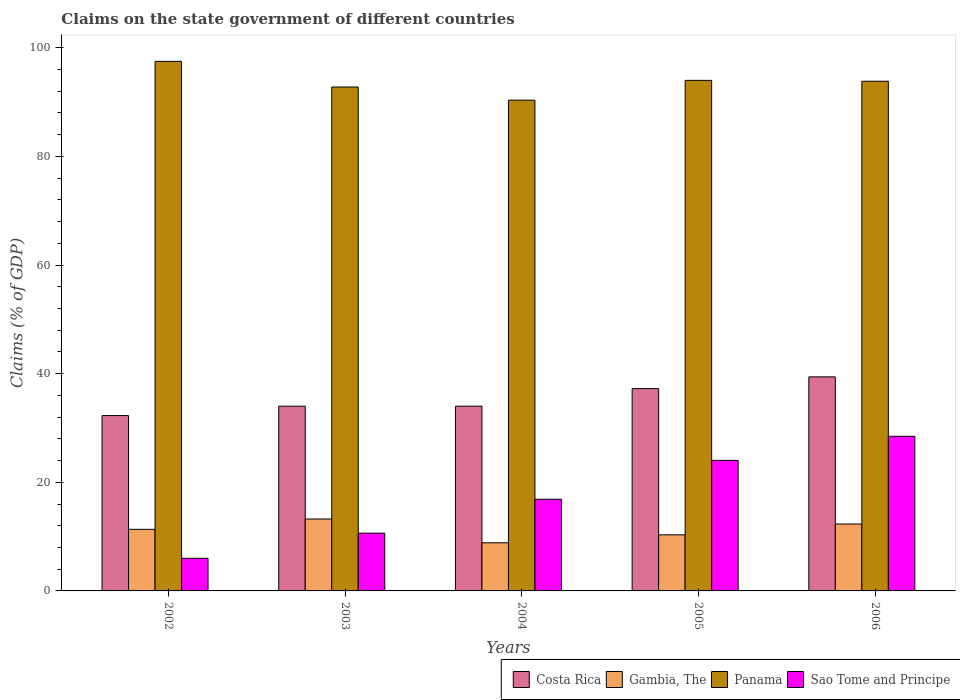Are the number of bars on each tick of the X-axis equal?
Give a very brief answer. Yes. How many bars are there on the 2nd tick from the right?
Give a very brief answer. 4. What is the percentage of GDP claimed on the state government in Panama in 2002?
Your response must be concise. 97.5. Across all years, what is the maximum percentage of GDP claimed on the state government in Costa Rica?
Provide a succinct answer. 39.41. Across all years, what is the minimum percentage of GDP claimed on the state government in Panama?
Give a very brief answer. 90.35. In which year was the percentage of GDP claimed on the state government in Sao Tome and Principe maximum?
Provide a succinct answer. 2006. In which year was the percentage of GDP claimed on the state government in Gambia, The minimum?
Your answer should be very brief. 2004. What is the total percentage of GDP claimed on the state government in Costa Rica in the graph?
Keep it short and to the point. 176.97. What is the difference between the percentage of GDP claimed on the state government in Gambia, The in 2004 and that in 2005?
Provide a succinct answer. -1.46. What is the difference between the percentage of GDP claimed on the state government in Sao Tome and Principe in 2005 and the percentage of GDP claimed on the state government in Gambia, The in 2002?
Your answer should be very brief. 12.7. What is the average percentage of GDP claimed on the state government in Costa Rica per year?
Provide a short and direct response. 35.39. In the year 2002, what is the difference between the percentage of GDP claimed on the state government in Costa Rica and percentage of GDP claimed on the state government in Gambia, The?
Keep it short and to the point. 20.94. In how many years, is the percentage of GDP claimed on the state government in Costa Rica greater than 56 %?
Your answer should be compact. 0. What is the ratio of the percentage of GDP claimed on the state government in Sao Tome and Principe in 2003 to that in 2005?
Your response must be concise. 0.44. Is the percentage of GDP claimed on the state government in Panama in 2003 less than that in 2004?
Provide a short and direct response. No. Is the difference between the percentage of GDP claimed on the state government in Costa Rica in 2004 and 2005 greater than the difference between the percentage of GDP claimed on the state government in Gambia, The in 2004 and 2005?
Your response must be concise. No. What is the difference between the highest and the second highest percentage of GDP claimed on the state government in Gambia, The?
Provide a succinct answer. 0.92. What is the difference between the highest and the lowest percentage of GDP claimed on the state government in Costa Rica?
Ensure brevity in your answer.  7.13. In how many years, is the percentage of GDP claimed on the state government in Panama greater than the average percentage of GDP claimed on the state government in Panama taken over all years?
Ensure brevity in your answer.  3. Is it the case that in every year, the sum of the percentage of GDP claimed on the state government in Sao Tome and Principe and percentage of GDP claimed on the state government in Gambia, The is greater than the sum of percentage of GDP claimed on the state government in Panama and percentage of GDP claimed on the state government in Costa Rica?
Provide a succinct answer. No. What does the 4th bar from the left in 2004 represents?
Your response must be concise. Sao Tome and Principe. What does the 1st bar from the right in 2005 represents?
Give a very brief answer. Sao Tome and Principe. Is it the case that in every year, the sum of the percentage of GDP claimed on the state government in Costa Rica and percentage of GDP claimed on the state government in Gambia, The is greater than the percentage of GDP claimed on the state government in Panama?
Give a very brief answer. No. Are all the bars in the graph horizontal?
Keep it short and to the point. No. Are the values on the major ticks of Y-axis written in scientific E-notation?
Offer a very short reply. No. Where does the legend appear in the graph?
Your answer should be compact. Bottom right. How many legend labels are there?
Your answer should be compact. 4. What is the title of the graph?
Your answer should be compact. Claims on the state government of different countries. Does "Belarus" appear as one of the legend labels in the graph?
Ensure brevity in your answer.  No. What is the label or title of the Y-axis?
Make the answer very short. Claims (% of GDP). What is the Claims (% of GDP) in Costa Rica in 2002?
Provide a succinct answer. 32.28. What is the Claims (% of GDP) of Gambia, The in 2002?
Give a very brief answer. 11.34. What is the Claims (% of GDP) of Panama in 2002?
Provide a succinct answer. 97.5. What is the Claims (% of GDP) in Sao Tome and Principe in 2002?
Your answer should be compact. 6.01. What is the Claims (% of GDP) of Costa Rica in 2003?
Keep it short and to the point. 34.01. What is the Claims (% of GDP) of Gambia, The in 2003?
Offer a terse response. 13.24. What is the Claims (% of GDP) of Panama in 2003?
Your answer should be compact. 92.78. What is the Claims (% of GDP) in Sao Tome and Principe in 2003?
Offer a terse response. 10.64. What is the Claims (% of GDP) of Costa Rica in 2004?
Give a very brief answer. 34.02. What is the Claims (% of GDP) in Gambia, The in 2004?
Ensure brevity in your answer.  8.86. What is the Claims (% of GDP) of Panama in 2004?
Your answer should be very brief. 90.35. What is the Claims (% of GDP) in Sao Tome and Principe in 2004?
Your answer should be very brief. 16.88. What is the Claims (% of GDP) in Costa Rica in 2005?
Ensure brevity in your answer.  37.25. What is the Claims (% of GDP) in Gambia, The in 2005?
Offer a terse response. 10.32. What is the Claims (% of GDP) in Panama in 2005?
Offer a terse response. 94. What is the Claims (% of GDP) in Sao Tome and Principe in 2005?
Your answer should be compact. 24.04. What is the Claims (% of GDP) in Costa Rica in 2006?
Give a very brief answer. 39.41. What is the Claims (% of GDP) of Gambia, The in 2006?
Your answer should be compact. 12.32. What is the Claims (% of GDP) in Panama in 2006?
Make the answer very short. 93.84. What is the Claims (% of GDP) in Sao Tome and Principe in 2006?
Offer a terse response. 28.47. Across all years, what is the maximum Claims (% of GDP) of Costa Rica?
Your answer should be compact. 39.41. Across all years, what is the maximum Claims (% of GDP) in Gambia, The?
Make the answer very short. 13.24. Across all years, what is the maximum Claims (% of GDP) of Panama?
Offer a very short reply. 97.5. Across all years, what is the maximum Claims (% of GDP) in Sao Tome and Principe?
Your response must be concise. 28.47. Across all years, what is the minimum Claims (% of GDP) of Costa Rica?
Your answer should be compact. 32.28. Across all years, what is the minimum Claims (% of GDP) in Gambia, The?
Keep it short and to the point. 8.86. Across all years, what is the minimum Claims (% of GDP) of Panama?
Your response must be concise. 90.35. Across all years, what is the minimum Claims (% of GDP) of Sao Tome and Principe?
Your answer should be compact. 6.01. What is the total Claims (% of GDP) in Costa Rica in the graph?
Offer a very short reply. 176.97. What is the total Claims (% of GDP) of Gambia, The in the graph?
Ensure brevity in your answer.  56.08. What is the total Claims (% of GDP) in Panama in the graph?
Ensure brevity in your answer.  468.46. What is the total Claims (% of GDP) of Sao Tome and Principe in the graph?
Keep it short and to the point. 86.03. What is the difference between the Claims (% of GDP) in Costa Rica in 2002 and that in 2003?
Provide a short and direct response. -1.73. What is the difference between the Claims (% of GDP) in Gambia, The in 2002 and that in 2003?
Provide a succinct answer. -1.9. What is the difference between the Claims (% of GDP) of Panama in 2002 and that in 2003?
Your answer should be very brief. 4.72. What is the difference between the Claims (% of GDP) of Sao Tome and Principe in 2002 and that in 2003?
Offer a terse response. -4.63. What is the difference between the Claims (% of GDP) in Costa Rica in 2002 and that in 2004?
Provide a succinct answer. -1.73. What is the difference between the Claims (% of GDP) of Gambia, The in 2002 and that in 2004?
Ensure brevity in your answer.  2.48. What is the difference between the Claims (% of GDP) of Panama in 2002 and that in 2004?
Provide a short and direct response. 7.15. What is the difference between the Claims (% of GDP) of Sao Tome and Principe in 2002 and that in 2004?
Offer a very short reply. -10.87. What is the difference between the Claims (% of GDP) in Costa Rica in 2002 and that in 2005?
Provide a succinct answer. -4.96. What is the difference between the Claims (% of GDP) of Gambia, The in 2002 and that in 2005?
Keep it short and to the point. 1.01. What is the difference between the Claims (% of GDP) in Panama in 2002 and that in 2005?
Provide a succinct answer. 3.5. What is the difference between the Claims (% of GDP) in Sao Tome and Principe in 2002 and that in 2005?
Your response must be concise. -18.03. What is the difference between the Claims (% of GDP) in Costa Rica in 2002 and that in 2006?
Your answer should be very brief. -7.13. What is the difference between the Claims (% of GDP) in Gambia, The in 2002 and that in 2006?
Provide a succinct answer. -0.98. What is the difference between the Claims (% of GDP) in Panama in 2002 and that in 2006?
Offer a terse response. 3.66. What is the difference between the Claims (% of GDP) in Sao Tome and Principe in 2002 and that in 2006?
Make the answer very short. -22.46. What is the difference between the Claims (% of GDP) of Costa Rica in 2003 and that in 2004?
Provide a succinct answer. -0. What is the difference between the Claims (% of GDP) in Gambia, The in 2003 and that in 2004?
Provide a succinct answer. 4.38. What is the difference between the Claims (% of GDP) in Panama in 2003 and that in 2004?
Give a very brief answer. 2.42. What is the difference between the Claims (% of GDP) of Sao Tome and Principe in 2003 and that in 2004?
Make the answer very short. -6.24. What is the difference between the Claims (% of GDP) of Costa Rica in 2003 and that in 2005?
Provide a succinct answer. -3.23. What is the difference between the Claims (% of GDP) in Gambia, The in 2003 and that in 2005?
Offer a very short reply. 2.92. What is the difference between the Claims (% of GDP) of Panama in 2003 and that in 2005?
Your response must be concise. -1.22. What is the difference between the Claims (% of GDP) of Sao Tome and Principe in 2003 and that in 2005?
Offer a very short reply. -13.4. What is the difference between the Claims (% of GDP) of Costa Rica in 2003 and that in 2006?
Your response must be concise. -5.4. What is the difference between the Claims (% of GDP) of Gambia, The in 2003 and that in 2006?
Provide a succinct answer. 0.92. What is the difference between the Claims (% of GDP) of Panama in 2003 and that in 2006?
Keep it short and to the point. -1.06. What is the difference between the Claims (% of GDP) in Sao Tome and Principe in 2003 and that in 2006?
Provide a succinct answer. -17.83. What is the difference between the Claims (% of GDP) of Costa Rica in 2004 and that in 2005?
Your answer should be compact. -3.23. What is the difference between the Claims (% of GDP) of Gambia, The in 2004 and that in 2005?
Provide a short and direct response. -1.46. What is the difference between the Claims (% of GDP) in Panama in 2004 and that in 2005?
Ensure brevity in your answer.  -3.64. What is the difference between the Claims (% of GDP) of Sao Tome and Principe in 2004 and that in 2005?
Your answer should be compact. -7.16. What is the difference between the Claims (% of GDP) in Costa Rica in 2004 and that in 2006?
Your answer should be compact. -5.39. What is the difference between the Claims (% of GDP) of Gambia, The in 2004 and that in 2006?
Offer a terse response. -3.46. What is the difference between the Claims (% of GDP) of Panama in 2004 and that in 2006?
Give a very brief answer. -3.48. What is the difference between the Claims (% of GDP) of Sao Tome and Principe in 2004 and that in 2006?
Provide a succinct answer. -11.59. What is the difference between the Claims (% of GDP) in Costa Rica in 2005 and that in 2006?
Your response must be concise. -2.16. What is the difference between the Claims (% of GDP) of Gambia, The in 2005 and that in 2006?
Offer a very short reply. -1.99. What is the difference between the Claims (% of GDP) of Panama in 2005 and that in 2006?
Provide a succinct answer. 0.16. What is the difference between the Claims (% of GDP) in Sao Tome and Principe in 2005 and that in 2006?
Offer a very short reply. -4.43. What is the difference between the Claims (% of GDP) of Costa Rica in 2002 and the Claims (% of GDP) of Gambia, The in 2003?
Your response must be concise. 19.04. What is the difference between the Claims (% of GDP) in Costa Rica in 2002 and the Claims (% of GDP) in Panama in 2003?
Your answer should be very brief. -60.49. What is the difference between the Claims (% of GDP) in Costa Rica in 2002 and the Claims (% of GDP) in Sao Tome and Principe in 2003?
Provide a succinct answer. 21.65. What is the difference between the Claims (% of GDP) of Gambia, The in 2002 and the Claims (% of GDP) of Panama in 2003?
Provide a succinct answer. -81.44. What is the difference between the Claims (% of GDP) of Gambia, The in 2002 and the Claims (% of GDP) of Sao Tome and Principe in 2003?
Provide a short and direct response. 0.7. What is the difference between the Claims (% of GDP) of Panama in 2002 and the Claims (% of GDP) of Sao Tome and Principe in 2003?
Provide a succinct answer. 86.86. What is the difference between the Claims (% of GDP) in Costa Rica in 2002 and the Claims (% of GDP) in Gambia, The in 2004?
Provide a short and direct response. 23.42. What is the difference between the Claims (% of GDP) in Costa Rica in 2002 and the Claims (% of GDP) in Panama in 2004?
Make the answer very short. -58.07. What is the difference between the Claims (% of GDP) in Costa Rica in 2002 and the Claims (% of GDP) in Sao Tome and Principe in 2004?
Provide a short and direct response. 15.4. What is the difference between the Claims (% of GDP) of Gambia, The in 2002 and the Claims (% of GDP) of Panama in 2004?
Offer a terse response. -79.01. What is the difference between the Claims (% of GDP) of Gambia, The in 2002 and the Claims (% of GDP) of Sao Tome and Principe in 2004?
Give a very brief answer. -5.54. What is the difference between the Claims (% of GDP) in Panama in 2002 and the Claims (% of GDP) in Sao Tome and Principe in 2004?
Ensure brevity in your answer.  80.62. What is the difference between the Claims (% of GDP) in Costa Rica in 2002 and the Claims (% of GDP) in Gambia, The in 2005?
Ensure brevity in your answer.  21.96. What is the difference between the Claims (% of GDP) in Costa Rica in 2002 and the Claims (% of GDP) in Panama in 2005?
Offer a very short reply. -61.71. What is the difference between the Claims (% of GDP) in Costa Rica in 2002 and the Claims (% of GDP) in Sao Tome and Principe in 2005?
Offer a very short reply. 8.25. What is the difference between the Claims (% of GDP) of Gambia, The in 2002 and the Claims (% of GDP) of Panama in 2005?
Provide a short and direct response. -82.66. What is the difference between the Claims (% of GDP) in Gambia, The in 2002 and the Claims (% of GDP) in Sao Tome and Principe in 2005?
Make the answer very short. -12.7. What is the difference between the Claims (% of GDP) of Panama in 2002 and the Claims (% of GDP) of Sao Tome and Principe in 2005?
Your answer should be very brief. 73.46. What is the difference between the Claims (% of GDP) of Costa Rica in 2002 and the Claims (% of GDP) of Gambia, The in 2006?
Your answer should be very brief. 19.97. What is the difference between the Claims (% of GDP) in Costa Rica in 2002 and the Claims (% of GDP) in Panama in 2006?
Your response must be concise. -61.55. What is the difference between the Claims (% of GDP) in Costa Rica in 2002 and the Claims (% of GDP) in Sao Tome and Principe in 2006?
Make the answer very short. 3.81. What is the difference between the Claims (% of GDP) in Gambia, The in 2002 and the Claims (% of GDP) in Panama in 2006?
Ensure brevity in your answer.  -82.5. What is the difference between the Claims (% of GDP) in Gambia, The in 2002 and the Claims (% of GDP) in Sao Tome and Principe in 2006?
Your answer should be compact. -17.13. What is the difference between the Claims (% of GDP) of Panama in 2002 and the Claims (% of GDP) of Sao Tome and Principe in 2006?
Give a very brief answer. 69.03. What is the difference between the Claims (% of GDP) in Costa Rica in 2003 and the Claims (% of GDP) in Gambia, The in 2004?
Provide a short and direct response. 25.15. What is the difference between the Claims (% of GDP) in Costa Rica in 2003 and the Claims (% of GDP) in Panama in 2004?
Offer a terse response. -56.34. What is the difference between the Claims (% of GDP) of Costa Rica in 2003 and the Claims (% of GDP) of Sao Tome and Principe in 2004?
Keep it short and to the point. 17.13. What is the difference between the Claims (% of GDP) of Gambia, The in 2003 and the Claims (% of GDP) of Panama in 2004?
Your answer should be very brief. -77.11. What is the difference between the Claims (% of GDP) in Gambia, The in 2003 and the Claims (% of GDP) in Sao Tome and Principe in 2004?
Ensure brevity in your answer.  -3.64. What is the difference between the Claims (% of GDP) of Panama in 2003 and the Claims (% of GDP) of Sao Tome and Principe in 2004?
Your answer should be very brief. 75.9. What is the difference between the Claims (% of GDP) in Costa Rica in 2003 and the Claims (% of GDP) in Gambia, The in 2005?
Provide a short and direct response. 23.69. What is the difference between the Claims (% of GDP) in Costa Rica in 2003 and the Claims (% of GDP) in Panama in 2005?
Offer a terse response. -59.98. What is the difference between the Claims (% of GDP) in Costa Rica in 2003 and the Claims (% of GDP) in Sao Tome and Principe in 2005?
Your answer should be compact. 9.98. What is the difference between the Claims (% of GDP) in Gambia, The in 2003 and the Claims (% of GDP) in Panama in 2005?
Ensure brevity in your answer.  -80.76. What is the difference between the Claims (% of GDP) of Gambia, The in 2003 and the Claims (% of GDP) of Sao Tome and Principe in 2005?
Offer a very short reply. -10.8. What is the difference between the Claims (% of GDP) of Panama in 2003 and the Claims (% of GDP) of Sao Tome and Principe in 2005?
Ensure brevity in your answer.  68.74. What is the difference between the Claims (% of GDP) of Costa Rica in 2003 and the Claims (% of GDP) of Gambia, The in 2006?
Keep it short and to the point. 21.7. What is the difference between the Claims (% of GDP) in Costa Rica in 2003 and the Claims (% of GDP) in Panama in 2006?
Your response must be concise. -59.82. What is the difference between the Claims (% of GDP) of Costa Rica in 2003 and the Claims (% of GDP) of Sao Tome and Principe in 2006?
Your answer should be compact. 5.54. What is the difference between the Claims (% of GDP) of Gambia, The in 2003 and the Claims (% of GDP) of Panama in 2006?
Provide a succinct answer. -80.6. What is the difference between the Claims (% of GDP) of Gambia, The in 2003 and the Claims (% of GDP) of Sao Tome and Principe in 2006?
Your response must be concise. -15.23. What is the difference between the Claims (% of GDP) of Panama in 2003 and the Claims (% of GDP) of Sao Tome and Principe in 2006?
Offer a terse response. 64.31. What is the difference between the Claims (% of GDP) in Costa Rica in 2004 and the Claims (% of GDP) in Gambia, The in 2005?
Your answer should be very brief. 23.69. What is the difference between the Claims (% of GDP) of Costa Rica in 2004 and the Claims (% of GDP) of Panama in 2005?
Keep it short and to the point. -59.98. What is the difference between the Claims (% of GDP) of Costa Rica in 2004 and the Claims (% of GDP) of Sao Tome and Principe in 2005?
Ensure brevity in your answer.  9.98. What is the difference between the Claims (% of GDP) in Gambia, The in 2004 and the Claims (% of GDP) in Panama in 2005?
Your answer should be compact. -85.14. What is the difference between the Claims (% of GDP) of Gambia, The in 2004 and the Claims (% of GDP) of Sao Tome and Principe in 2005?
Offer a very short reply. -15.17. What is the difference between the Claims (% of GDP) in Panama in 2004 and the Claims (% of GDP) in Sao Tome and Principe in 2005?
Your response must be concise. 66.32. What is the difference between the Claims (% of GDP) in Costa Rica in 2004 and the Claims (% of GDP) in Gambia, The in 2006?
Give a very brief answer. 21.7. What is the difference between the Claims (% of GDP) in Costa Rica in 2004 and the Claims (% of GDP) in Panama in 2006?
Provide a succinct answer. -59.82. What is the difference between the Claims (% of GDP) in Costa Rica in 2004 and the Claims (% of GDP) in Sao Tome and Principe in 2006?
Give a very brief answer. 5.55. What is the difference between the Claims (% of GDP) in Gambia, The in 2004 and the Claims (% of GDP) in Panama in 2006?
Provide a succinct answer. -84.97. What is the difference between the Claims (% of GDP) in Gambia, The in 2004 and the Claims (% of GDP) in Sao Tome and Principe in 2006?
Your answer should be very brief. -19.61. What is the difference between the Claims (% of GDP) in Panama in 2004 and the Claims (% of GDP) in Sao Tome and Principe in 2006?
Give a very brief answer. 61.88. What is the difference between the Claims (% of GDP) in Costa Rica in 2005 and the Claims (% of GDP) in Gambia, The in 2006?
Give a very brief answer. 24.93. What is the difference between the Claims (% of GDP) in Costa Rica in 2005 and the Claims (% of GDP) in Panama in 2006?
Your answer should be compact. -56.59. What is the difference between the Claims (% of GDP) in Costa Rica in 2005 and the Claims (% of GDP) in Sao Tome and Principe in 2006?
Give a very brief answer. 8.78. What is the difference between the Claims (% of GDP) in Gambia, The in 2005 and the Claims (% of GDP) in Panama in 2006?
Provide a short and direct response. -83.51. What is the difference between the Claims (% of GDP) in Gambia, The in 2005 and the Claims (% of GDP) in Sao Tome and Principe in 2006?
Keep it short and to the point. -18.15. What is the difference between the Claims (% of GDP) of Panama in 2005 and the Claims (% of GDP) of Sao Tome and Principe in 2006?
Your answer should be very brief. 65.53. What is the average Claims (% of GDP) of Costa Rica per year?
Offer a very short reply. 35.39. What is the average Claims (% of GDP) in Gambia, The per year?
Offer a very short reply. 11.22. What is the average Claims (% of GDP) of Panama per year?
Your response must be concise. 93.69. What is the average Claims (% of GDP) of Sao Tome and Principe per year?
Provide a succinct answer. 17.21. In the year 2002, what is the difference between the Claims (% of GDP) of Costa Rica and Claims (% of GDP) of Gambia, The?
Give a very brief answer. 20.94. In the year 2002, what is the difference between the Claims (% of GDP) of Costa Rica and Claims (% of GDP) of Panama?
Make the answer very short. -65.22. In the year 2002, what is the difference between the Claims (% of GDP) of Costa Rica and Claims (% of GDP) of Sao Tome and Principe?
Your response must be concise. 26.28. In the year 2002, what is the difference between the Claims (% of GDP) of Gambia, The and Claims (% of GDP) of Panama?
Make the answer very short. -86.16. In the year 2002, what is the difference between the Claims (% of GDP) of Gambia, The and Claims (% of GDP) of Sao Tome and Principe?
Your answer should be very brief. 5.33. In the year 2002, what is the difference between the Claims (% of GDP) in Panama and Claims (% of GDP) in Sao Tome and Principe?
Provide a succinct answer. 91.49. In the year 2003, what is the difference between the Claims (% of GDP) of Costa Rica and Claims (% of GDP) of Gambia, The?
Your response must be concise. 20.77. In the year 2003, what is the difference between the Claims (% of GDP) of Costa Rica and Claims (% of GDP) of Panama?
Offer a terse response. -58.76. In the year 2003, what is the difference between the Claims (% of GDP) in Costa Rica and Claims (% of GDP) in Sao Tome and Principe?
Offer a terse response. 23.38. In the year 2003, what is the difference between the Claims (% of GDP) of Gambia, The and Claims (% of GDP) of Panama?
Your response must be concise. -79.54. In the year 2003, what is the difference between the Claims (% of GDP) of Gambia, The and Claims (% of GDP) of Sao Tome and Principe?
Your answer should be very brief. 2.6. In the year 2003, what is the difference between the Claims (% of GDP) of Panama and Claims (% of GDP) of Sao Tome and Principe?
Give a very brief answer. 82.14. In the year 2004, what is the difference between the Claims (% of GDP) in Costa Rica and Claims (% of GDP) in Gambia, The?
Your answer should be compact. 25.16. In the year 2004, what is the difference between the Claims (% of GDP) in Costa Rica and Claims (% of GDP) in Panama?
Ensure brevity in your answer.  -56.34. In the year 2004, what is the difference between the Claims (% of GDP) of Costa Rica and Claims (% of GDP) of Sao Tome and Principe?
Your answer should be very brief. 17.14. In the year 2004, what is the difference between the Claims (% of GDP) of Gambia, The and Claims (% of GDP) of Panama?
Ensure brevity in your answer.  -81.49. In the year 2004, what is the difference between the Claims (% of GDP) in Gambia, The and Claims (% of GDP) in Sao Tome and Principe?
Keep it short and to the point. -8.02. In the year 2004, what is the difference between the Claims (% of GDP) in Panama and Claims (% of GDP) in Sao Tome and Principe?
Your answer should be very brief. 73.47. In the year 2005, what is the difference between the Claims (% of GDP) in Costa Rica and Claims (% of GDP) in Gambia, The?
Your response must be concise. 26.92. In the year 2005, what is the difference between the Claims (% of GDP) in Costa Rica and Claims (% of GDP) in Panama?
Make the answer very short. -56.75. In the year 2005, what is the difference between the Claims (% of GDP) of Costa Rica and Claims (% of GDP) of Sao Tome and Principe?
Ensure brevity in your answer.  13.21. In the year 2005, what is the difference between the Claims (% of GDP) of Gambia, The and Claims (% of GDP) of Panama?
Ensure brevity in your answer.  -83.67. In the year 2005, what is the difference between the Claims (% of GDP) of Gambia, The and Claims (% of GDP) of Sao Tome and Principe?
Make the answer very short. -13.71. In the year 2005, what is the difference between the Claims (% of GDP) in Panama and Claims (% of GDP) in Sao Tome and Principe?
Make the answer very short. 69.96. In the year 2006, what is the difference between the Claims (% of GDP) in Costa Rica and Claims (% of GDP) in Gambia, The?
Your response must be concise. 27.09. In the year 2006, what is the difference between the Claims (% of GDP) in Costa Rica and Claims (% of GDP) in Panama?
Provide a short and direct response. -54.43. In the year 2006, what is the difference between the Claims (% of GDP) of Costa Rica and Claims (% of GDP) of Sao Tome and Principe?
Your response must be concise. 10.94. In the year 2006, what is the difference between the Claims (% of GDP) in Gambia, The and Claims (% of GDP) in Panama?
Ensure brevity in your answer.  -81.52. In the year 2006, what is the difference between the Claims (% of GDP) of Gambia, The and Claims (% of GDP) of Sao Tome and Principe?
Provide a succinct answer. -16.15. In the year 2006, what is the difference between the Claims (% of GDP) in Panama and Claims (% of GDP) in Sao Tome and Principe?
Offer a terse response. 65.37. What is the ratio of the Claims (% of GDP) of Costa Rica in 2002 to that in 2003?
Your response must be concise. 0.95. What is the ratio of the Claims (% of GDP) of Gambia, The in 2002 to that in 2003?
Make the answer very short. 0.86. What is the ratio of the Claims (% of GDP) of Panama in 2002 to that in 2003?
Keep it short and to the point. 1.05. What is the ratio of the Claims (% of GDP) of Sao Tome and Principe in 2002 to that in 2003?
Provide a short and direct response. 0.56. What is the ratio of the Claims (% of GDP) in Costa Rica in 2002 to that in 2004?
Ensure brevity in your answer.  0.95. What is the ratio of the Claims (% of GDP) in Gambia, The in 2002 to that in 2004?
Provide a short and direct response. 1.28. What is the ratio of the Claims (% of GDP) in Panama in 2002 to that in 2004?
Keep it short and to the point. 1.08. What is the ratio of the Claims (% of GDP) in Sao Tome and Principe in 2002 to that in 2004?
Your response must be concise. 0.36. What is the ratio of the Claims (% of GDP) of Costa Rica in 2002 to that in 2005?
Your answer should be very brief. 0.87. What is the ratio of the Claims (% of GDP) in Gambia, The in 2002 to that in 2005?
Ensure brevity in your answer.  1.1. What is the ratio of the Claims (% of GDP) of Panama in 2002 to that in 2005?
Provide a succinct answer. 1.04. What is the ratio of the Claims (% of GDP) of Sao Tome and Principe in 2002 to that in 2005?
Your answer should be very brief. 0.25. What is the ratio of the Claims (% of GDP) in Costa Rica in 2002 to that in 2006?
Your answer should be compact. 0.82. What is the ratio of the Claims (% of GDP) of Gambia, The in 2002 to that in 2006?
Your response must be concise. 0.92. What is the ratio of the Claims (% of GDP) in Panama in 2002 to that in 2006?
Ensure brevity in your answer.  1.04. What is the ratio of the Claims (% of GDP) in Sao Tome and Principe in 2002 to that in 2006?
Your response must be concise. 0.21. What is the ratio of the Claims (% of GDP) of Gambia, The in 2003 to that in 2004?
Keep it short and to the point. 1.49. What is the ratio of the Claims (% of GDP) in Panama in 2003 to that in 2004?
Provide a succinct answer. 1.03. What is the ratio of the Claims (% of GDP) in Sao Tome and Principe in 2003 to that in 2004?
Make the answer very short. 0.63. What is the ratio of the Claims (% of GDP) in Costa Rica in 2003 to that in 2005?
Give a very brief answer. 0.91. What is the ratio of the Claims (% of GDP) of Gambia, The in 2003 to that in 2005?
Offer a terse response. 1.28. What is the ratio of the Claims (% of GDP) in Panama in 2003 to that in 2005?
Provide a short and direct response. 0.99. What is the ratio of the Claims (% of GDP) of Sao Tome and Principe in 2003 to that in 2005?
Your answer should be very brief. 0.44. What is the ratio of the Claims (% of GDP) of Costa Rica in 2003 to that in 2006?
Provide a short and direct response. 0.86. What is the ratio of the Claims (% of GDP) of Gambia, The in 2003 to that in 2006?
Provide a short and direct response. 1.07. What is the ratio of the Claims (% of GDP) of Panama in 2003 to that in 2006?
Keep it short and to the point. 0.99. What is the ratio of the Claims (% of GDP) in Sao Tome and Principe in 2003 to that in 2006?
Keep it short and to the point. 0.37. What is the ratio of the Claims (% of GDP) of Costa Rica in 2004 to that in 2005?
Your answer should be very brief. 0.91. What is the ratio of the Claims (% of GDP) of Gambia, The in 2004 to that in 2005?
Provide a succinct answer. 0.86. What is the ratio of the Claims (% of GDP) of Panama in 2004 to that in 2005?
Give a very brief answer. 0.96. What is the ratio of the Claims (% of GDP) of Sao Tome and Principe in 2004 to that in 2005?
Provide a succinct answer. 0.7. What is the ratio of the Claims (% of GDP) in Costa Rica in 2004 to that in 2006?
Your response must be concise. 0.86. What is the ratio of the Claims (% of GDP) of Gambia, The in 2004 to that in 2006?
Give a very brief answer. 0.72. What is the ratio of the Claims (% of GDP) in Panama in 2004 to that in 2006?
Your answer should be very brief. 0.96. What is the ratio of the Claims (% of GDP) of Sao Tome and Principe in 2004 to that in 2006?
Make the answer very short. 0.59. What is the ratio of the Claims (% of GDP) in Costa Rica in 2005 to that in 2006?
Give a very brief answer. 0.95. What is the ratio of the Claims (% of GDP) in Gambia, The in 2005 to that in 2006?
Provide a short and direct response. 0.84. What is the ratio of the Claims (% of GDP) in Sao Tome and Principe in 2005 to that in 2006?
Your answer should be very brief. 0.84. What is the difference between the highest and the second highest Claims (% of GDP) in Costa Rica?
Provide a short and direct response. 2.16. What is the difference between the highest and the second highest Claims (% of GDP) of Gambia, The?
Provide a succinct answer. 0.92. What is the difference between the highest and the second highest Claims (% of GDP) in Panama?
Your response must be concise. 3.5. What is the difference between the highest and the second highest Claims (% of GDP) of Sao Tome and Principe?
Provide a succinct answer. 4.43. What is the difference between the highest and the lowest Claims (% of GDP) of Costa Rica?
Give a very brief answer. 7.13. What is the difference between the highest and the lowest Claims (% of GDP) of Gambia, The?
Provide a succinct answer. 4.38. What is the difference between the highest and the lowest Claims (% of GDP) of Panama?
Keep it short and to the point. 7.15. What is the difference between the highest and the lowest Claims (% of GDP) of Sao Tome and Principe?
Your response must be concise. 22.46. 